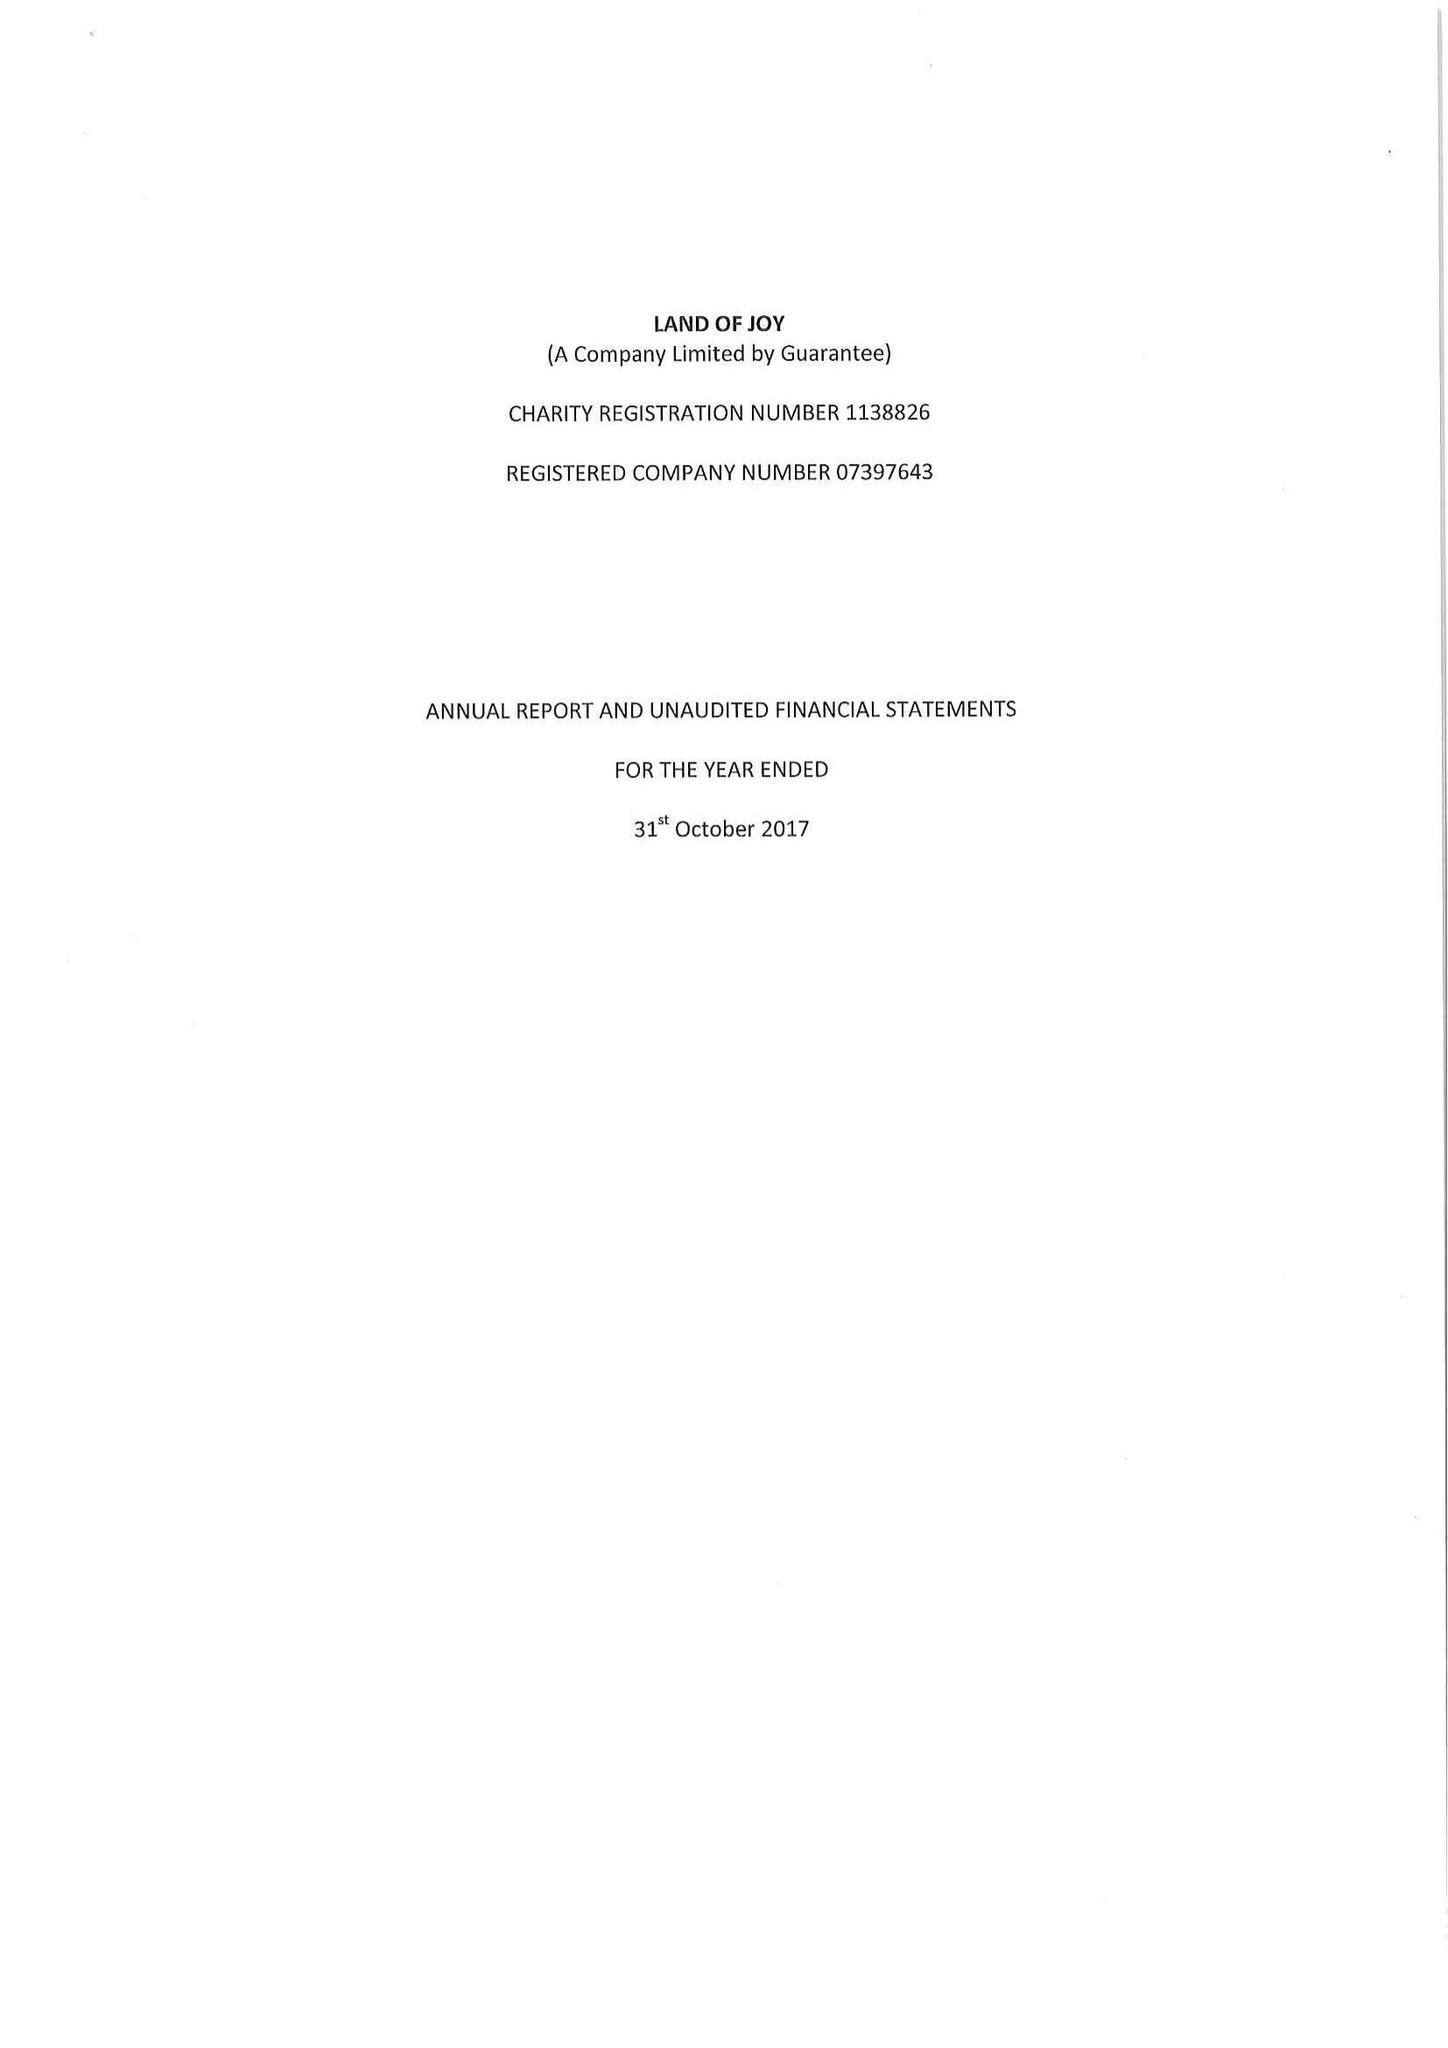What is the value for the address__post_town?
Answer the question using a single word or phrase. HEXHAM 